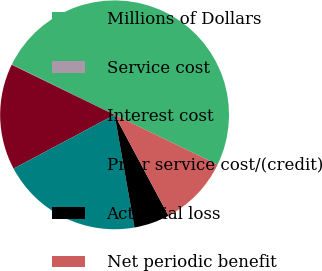<chart> <loc_0><loc_0><loc_500><loc_500><pie_chart><fcel>Millions of Dollars<fcel>Service cost<fcel>Interest cost<fcel>Prior service cost/(credit)<fcel>Actuarial loss<fcel>Net periodic benefit<nl><fcel>49.9%<fcel>0.05%<fcel>15.0%<fcel>19.99%<fcel>5.03%<fcel>10.02%<nl></chart> 